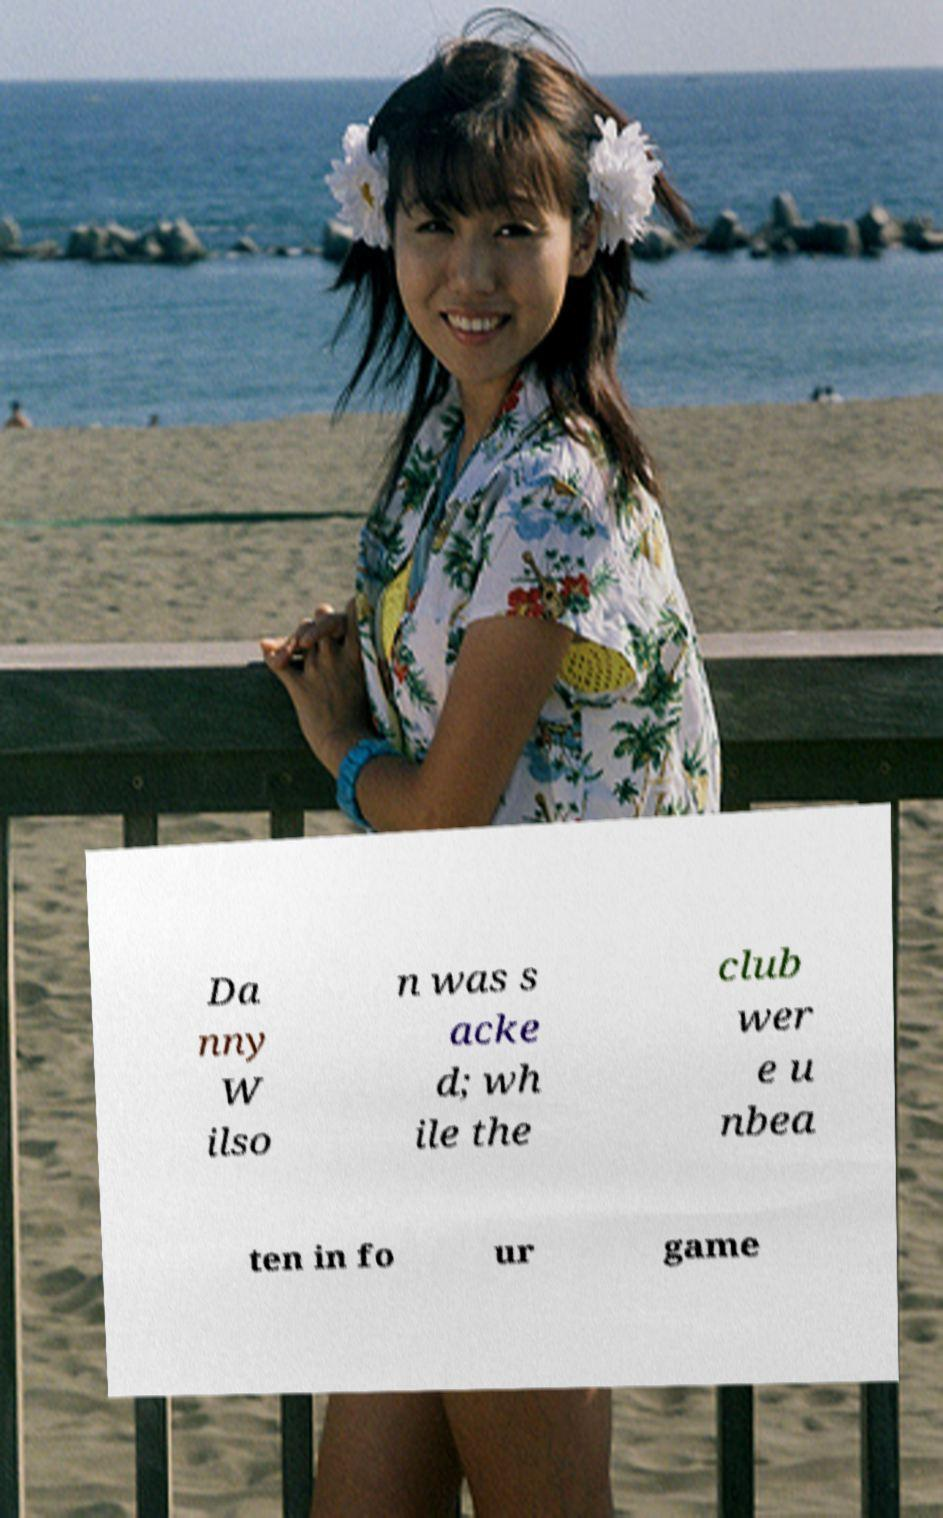I need the written content from this picture converted into text. Can you do that? Da nny W ilso n was s acke d; wh ile the club wer e u nbea ten in fo ur game 